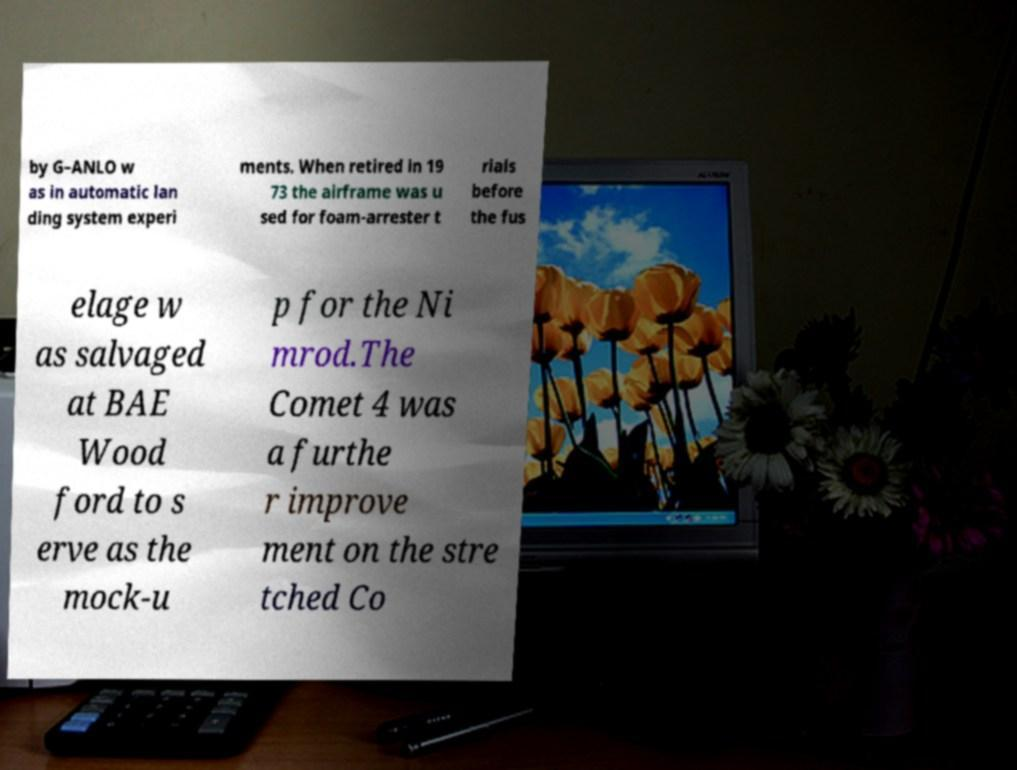Could you assist in decoding the text presented in this image and type it out clearly? by G–ANLO w as in automatic lan ding system experi ments. When retired in 19 73 the airframe was u sed for foam-arrester t rials before the fus elage w as salvaged at BAE Wood ford to s erve as the mock-u p for the Ni mrod.The Comet 4 was a furthe r improve ment on the stre tched Co 